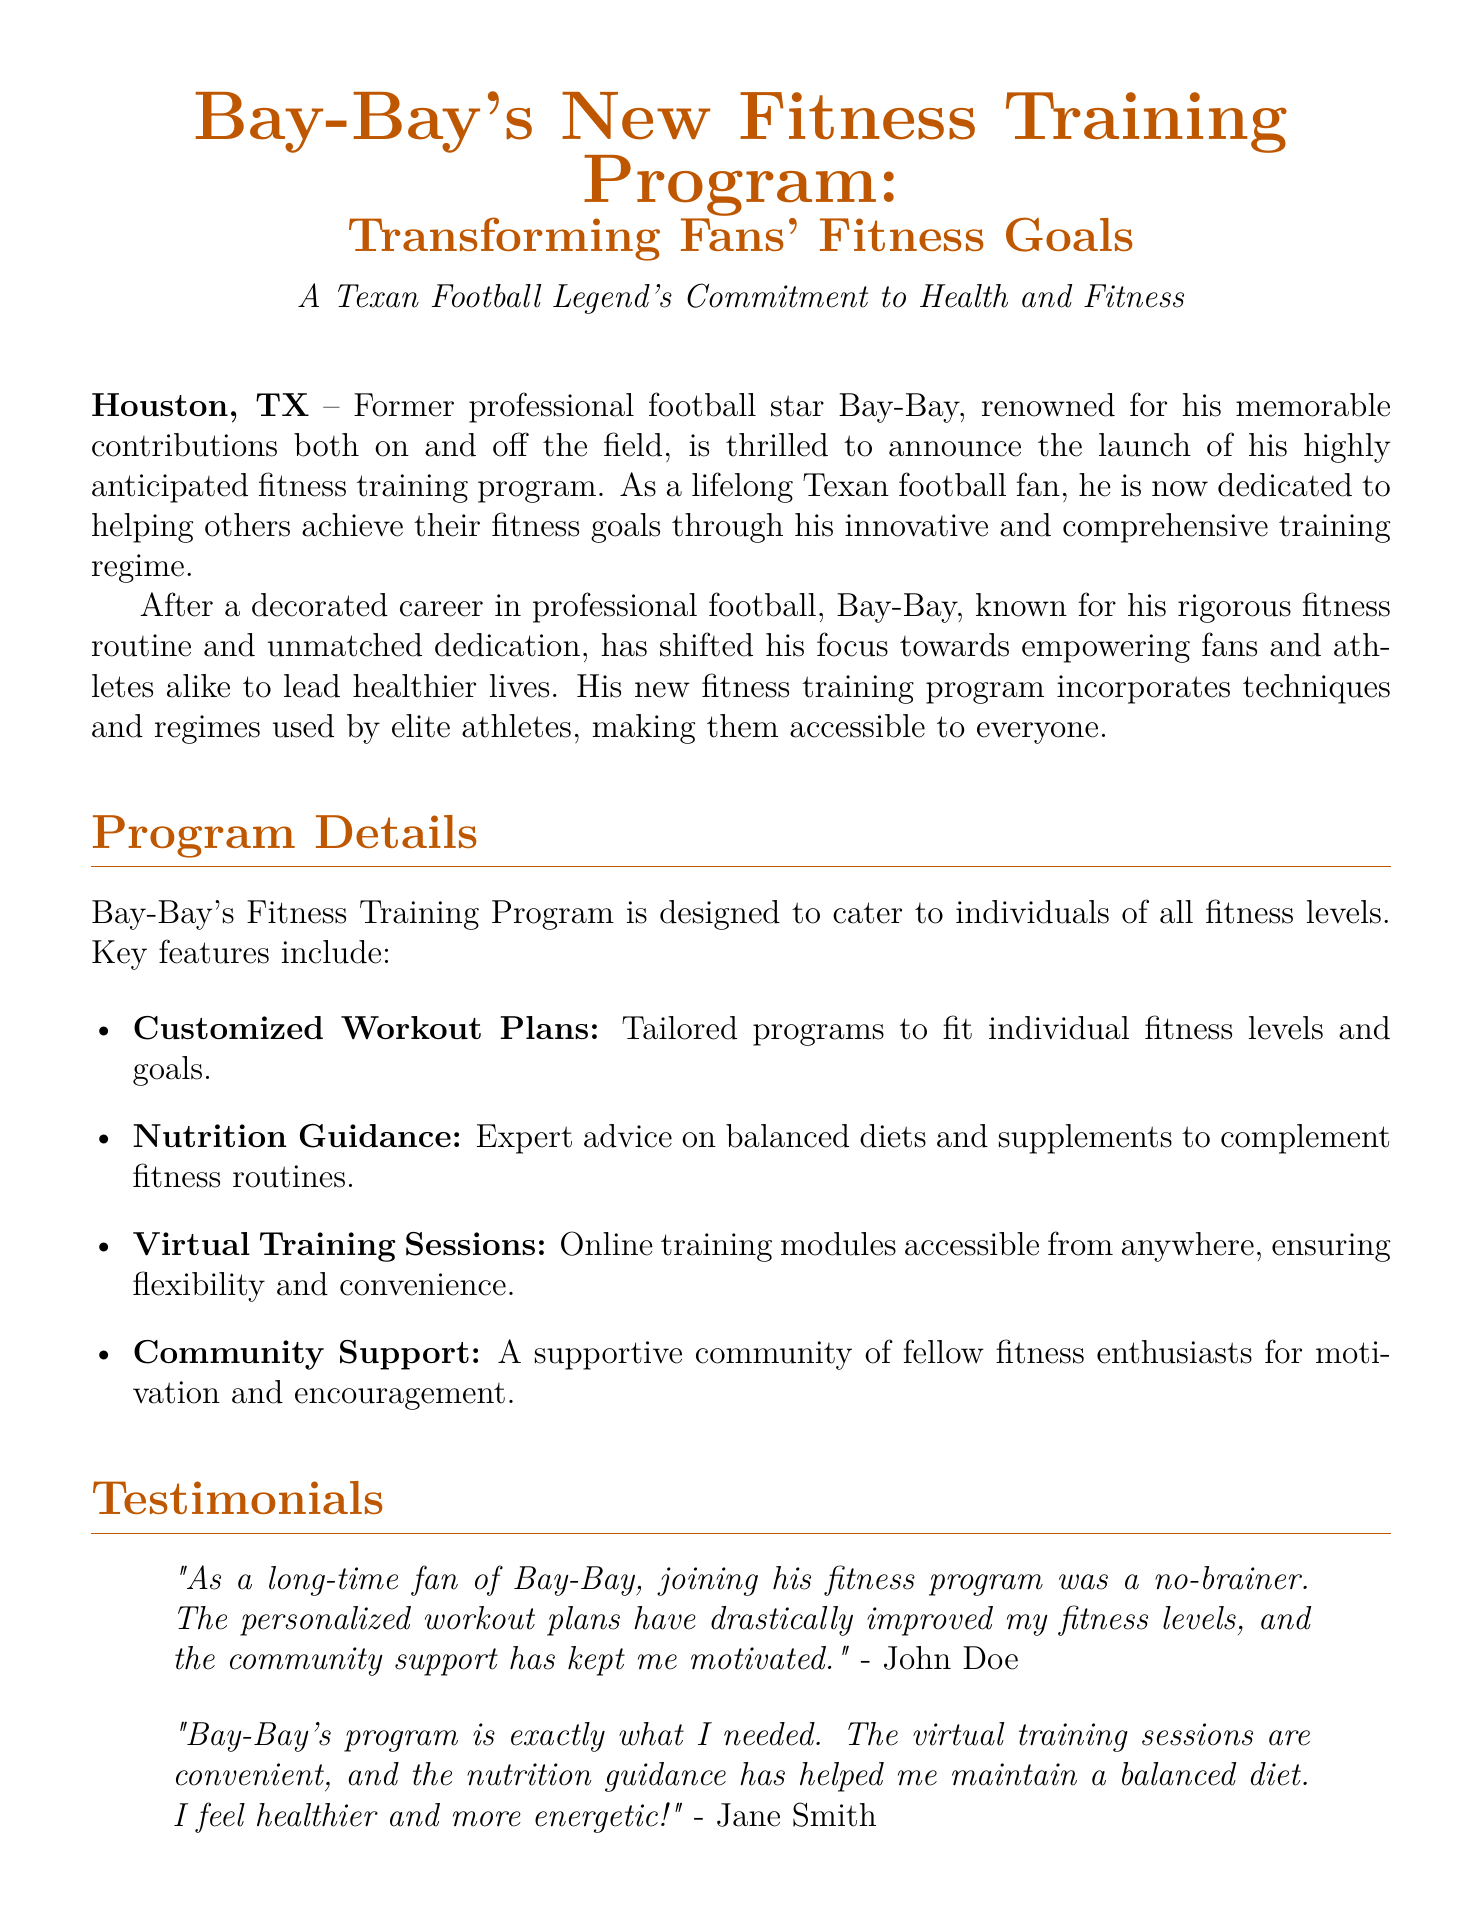What is the name of Bay-Bay's fitness training program? The name of the program is mentioned in the title of the press release.
Answer: Bay-Bay's New Fitness Training Program Where is Bay-Bay's fitness program based? The location is specified in the first line of the press release.
Answer: Houston, TX What feature of the program offers flexible accessibility? This feature is described under the Program Details section, emphasizing its convenience.
Answer: Virtual Training Sessions Who provided a testimonial about the program? The testimonials section mentions the names of two individuals who provided feedback.
Answer: John Doe and Jane Smith What type of support does the fitness program offer? The support aspect is highlighted in the Program Details section.
Answer: Community Support What is one of the main focuses of Bay-Bay's fitness initiative? The press release summarizes the program's goals and emphasis.
Answer: Holistic development What is the contact email for press inquiries? The email address is given at the end of the document under the contact information.
Answer: lisa.anderson@baybayfitness.com When considering fitness levels, what does the program provide? This aspect is explained in the Program Details section on personalized plans.
Answer: Customized Workout Plans What does Bay-Bay emphasize in his fitness training program? The underlying commitment is explained in the Contributions to Fitness section.
Answer: Health and fitness 